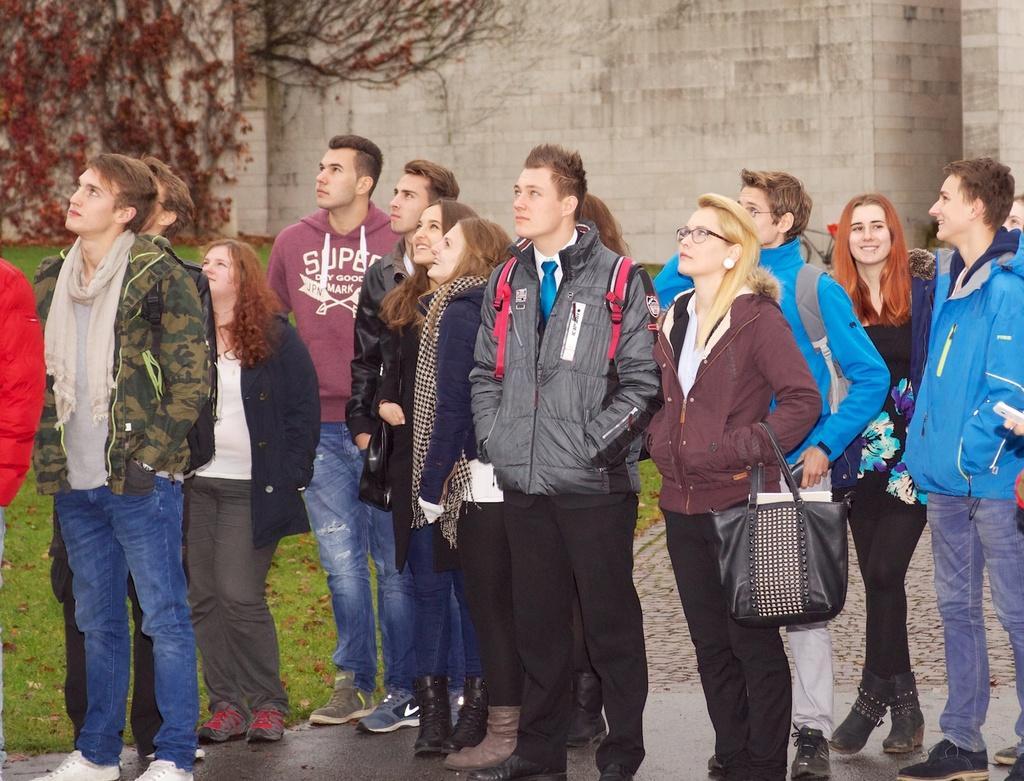Please provide a concise description of this image. In this image we can see many people standing. One lady is wearing specs and holding bag. In the back there is a wall with creepers. On the ground there is grass. 